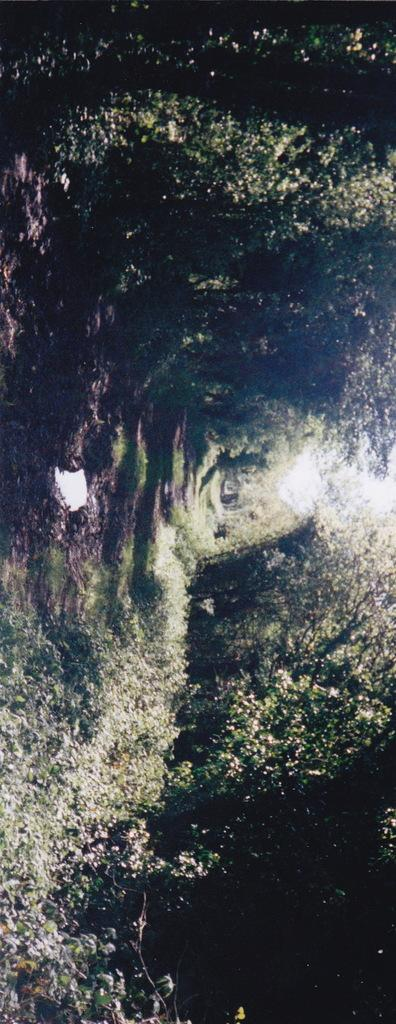What type of vegetation can be seen in the image? There are trees and plants in the image. Can you describe the overall appearance of the image? The image has a dark appearance. How many boys are carrying baskets in the image? There are no boys or baskets present in the image; it features trees and plants with a dark appearance. What type of apparel are the plants wearing in the image? Plants do not wear apparel, so this question cannot be answered. 